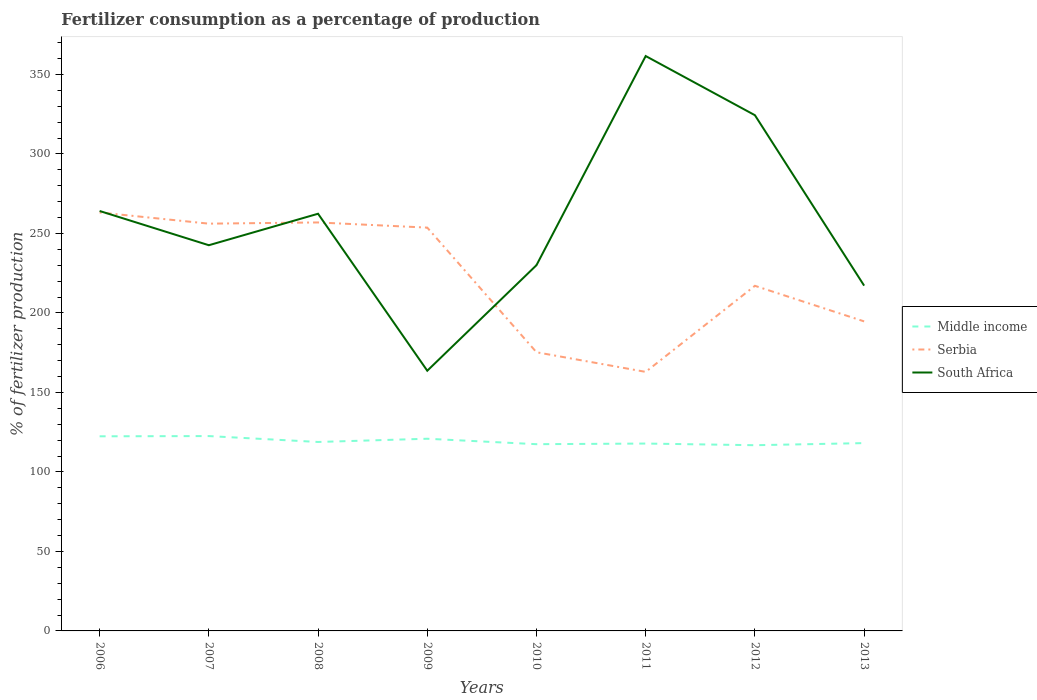How many different coloured lines are there?
Offer a terse response. 3. Across all years, what is the maximum percentage of fertilizers consumed in Serbia?
Provide a succinct answer. 162.92. What is the total percentage of fertilizers consumed in South Africa in the graph?
Make the answer very short. -118.98. What is the difference between the highest and the second highest percentage of fertilizers consumed in Middle income?
Your answer should be very brief. 5.74. How many lines are there?
Provide a short and direct response. 3. What is the difference between two consecutive major ticks on the Y-axis?
Offer a very short reply. 50. Where does the legend appear in the graph?
Keep it short and to the point. Center right. What is the title of the graph?
Offer a terse response. Fertilizer consumption as a percentage of production. Does "Italy" appear as one of the legend labels in the graph?
Keep it short and to the point. No. What is the label or title of the X-axis?
Offer a terse response. Years. What is the label or title of the Y-axis?
Keep it short and to the point. % of fertilizer production. What is the % of fertilizer production in Middle income in 2006?
Offer a very short reply. 122.4. What is the % of fertilizer production of Serbia in 2006?
Provide a short and direct response. 263.16. What is the % of fertilizer production of South Africa in 2006?
Offer a very short reply. 264.1. What is the % of fertilizer production of Middle income in 2007?
Offer a very short reply. 122.54. What is the % of fertilizer production in Serbia in 2007?
Your response must be concise. 256.14. What is the % of fertilizer production of South Africa in 2007?
Offer a very short reply. 242.57. What is the % of fertilizer production in Middle income in 2008?
Give a very brief answer. 118.83. What is the % of fertilizer production of Serbia in 2008?
Provide a succinct answer. 256.9. What is the % of fertilizer production of South Africa in 2008?
Give a very brief answer. 262.37. What is the % of fertilizer production in Middle income in 2009?
Your response must be concise. 120.87. What is the % of fertilizer production in Serbia in 2009?
Offer a very short reply. 253.64. What is the % of fertilizer production in South Africa in 2009?
Give a very brief answer. 163.64. What is the % of fertilizer production in Middle income in 2010?
Offer a very short reply. 117.44. What is the % of fertilizer production in Serbia in 2010?
Offer a terse response. 175.26. What is the % of fertilizer production of South Africa in 2010?
Your answer should be compact. 230.02. What is the % of fertilizer production in Middle income in 2011?
Provide a succinct answer. 117.84. What is the % of fertilizer production in Serbia in 2011?
Your answer should be compact. 162.92. What is the % of fertilizer production of South Africa in 2011?
Make the answer very short. 361.56. What is the % of fertilizer production of Middle income in 2012?
Keep it short and to the point. 116.8. What is the % of fertilizer production of Serbia in 2012?
Offer a terse response. 217.05. What is the % of fertilizer production of South Africa in 2012?
Your answer should be compact. 324.34. What is the % of fertilizer production of Middle income in 2013?
Provide a short and direct response. 118.12. What is the % of fertilizer production in Serbia in 2013?
Your answer should be very brief. 194.67. What is the % of fertilizer production of South Africa in 2013?
Offer a terse response. 217.16. Across all years, what is the maximum % of fertilizer production in Middle income?
Ensure brevity in your answer.  122.54. Across all years, what is the maximum % of fertilizer production in Serbia?
Your response must be concise. 263.16. Across all years, what is the maximum % of fertilizer production of South Africa?
Offer a terse response. 361.56. Across all years, what is the minimum % of fertilizer production in Middle income?
Give a very brief answer. 116.8. Across all years, what is the minimum % of fertilizer production of Serbia?
Provide a succinct answer. 162.92. Across all years, what is the minimum % of fertilizer production in South Africa?
Your answer should be compact. 163.64. What is the total % of fertilizer production of Middle income in the graph?
Keep it short and to the point. 954.83. What is the total % of fertilizer production of Serbia in the graph?
Your response must be concise. 1779.73. What is the total % of fertilizer production in South Africa in the graph?
Offer a terse response. 2065.76. What is the difference between the % of fertilizer production of Middle income in 2006 and that in 2007?
Make the answer very short. -0.14. What is the difference between the % of fertilizer production of Serbia in 2006 and that in 2007?
Your answer should be very brief. 7.03. What is the difference between the % of fertilizer production in South Africa in 2006 and that in 2007?
Give a very brief answer. 21.53. What is the difference between the % of fertilizer production in Middle income in 2006 and that in 2008?
Offer a very short reply. 3.57. What is the difference between the % of fertilizer production of Serbia in 2006 and that in 2008?
Ensure brevity in your answer.  6.27. What is the difference between the % of fertilizer production in South Africa in 2006 and that in 2008?
Keep it short and to the point. 1.73. What is the difference between the % of fertilizer production of Middle income in 2006 and that in 2009?
Your response must be concise. 1.53. What is the difference between the % of fertilizer production of Serbia in 2006 and that in 2009?
Your response must be concise. 9.52. What is the difference between the % of fertilizer production in South Africa in 2006 and that in 2009?
Ensure brevity in your answer.  100.47. What is the difference between the % of fertilizer production in Middle income in 2006 and that in 2010?
Your answer should be very brief. 4.96. What is the difference between the % of fertilizer production of Serbia in 2006 and that in 2010?
Make the answer very short. 87.91. What is the difference between the % of fertilizer production in South Africa in 2006 and that in 2010?
Your answer should be compact. 34.08. What is the difference between the % of fertilizer production of Middle income in 2006 and that in 2011?
Your answer should be very brief. 4.56. What is the difference between the % of fertilizer production in Serbia in 2006 and that in 2011?
Your answer should be very brief. 100.25. What is the difference between the % of fertilizer production of South Africa in 2006 and that in 2011?
Offer a very short reply. -97.45. What is the difference between the % of fertilizer production in Middle income in 2006 and that in 2012?
Offer a very short reply. 5.6. What is the difference between the % of fertilizer production in Serbia in 2006 and that in 2012?
Your answer should be very brief. 46.12. What is the difference between the % of fertilizer production of South Africa in 2006 and that in 2012?
Your answer should be compact. -60.24. What is the difference between the % of fertilizer production of Middle income in 2006 and that in 2013?
Offer a terse response. 4.28. What is the difference between the % of fertilizer production of Serbia in 2006 and that in 2013?
Make the answer very short. 68.49. What is the difference between the % of fertilizer production in South Africa in 2006 and that in 2013?
Ensure brevity in your answer.  46.95. What is the difference between the % of fertilizer production in Middle income in 2007 and that in 2008?
Your answer should be compact. 3.71. What is the difference between the % of fertilizer production of Serbia in 2007 and that in 2008?
Ensure brevity in your answer.  -0.76. What is the difference between the % of fertilizer production in South Africa in 2007 and that in 2008?
Offer a terse response. -19.8. What is the difference between the % of fertilizer production of Middle income in 2007 and that in 2009?
Provide a succinct answer. 1.68. What is the difference between the % of fertilizer production in Serbia in 2007 and that in 2009?
Ensure brevity in your answer.  2.49. What is the difference between the % of fertilizer production in South Africa in 2007 and that in 2009?
Provide a succinct answer. 78.93. What is the difference between the % of fertilizer production in Middle income in 2007 and that in 2010?
Your answer should be very brief. 5.1. What is the difference between the % of fertilizer production of Serbia in 2007 and that in 2010?
Provide a short and direct response. 80.88. What is the difference between the % of fertilizer production of South Africa in 2007 and that in 2010?
Make the answer very short. 12.55. What is the difference between the % of fertilizer production in Middle income in 2007 and that in 2011?
Your answer should be very brief. 4.71. What is the difference between the % of fertilizer production in Serbia in 2007 and that in 2011?
Your answer should be very brief. 93.22. What is the difference between the % of fertilizer production in South Africa in 2007 and that in 2011?
Keep it short and to the point. -118.98. What is the difference between the % of fertilizer production of Middle income in 2007 and that in 2012?
Your answer should be very brief. 5.74. What is the difference between the % of fertilizer production in Serbia in 2007 and that in 2012?
Your answer should be very brief. 39.09. What is the difference between the % of fertilizer production in South Africa in 2007 and that in 2012?
Provide a short and direct response. -81.77. What is the difference between the % of fertilizer production in Middle income in 2007 and that in 2013?
Provide a succinct answer. 4.42. What is the difference between the % of fertilizer production of Serbia in 2007 and that in 2013?
Keep it short and to the point. 61.47. What is the difference between the % of fertilizer production of South Africa in 2007 and that in 2013?
Provide a succinct answer. 25.41. What is the difference between the % of fertilizer production in Middle income in 2008 and that in 2009?
Your answer should be very brief. -2.03. What is the difference between the % of fertilizer production of Serbia in 2008 and that in 2009?
Make the answer very short. 3.25. What is the difference between the % of fertilizer production of South Africa in 2008 and that in 2009?
Keep it short and to the point. 98.73. What is the difference between the % of fertilizer production of Middle income in 2008 and that in 2010?
Your answer should be compact. 1.39. What is the difference between the % of fertilizer production in Serbia in 2008 and that in 2010?
Your answer should be compact. 81.64. What is the difference between the % of fertilizer production in South Africa in 2008 and that in 2010?
Offer a terse response. 32.34. What is the difference between the % of fertilizer production of Serbia in 2008 and that in 2011?
Offer a very short reply. 93.98. What is the difference between the % of fertilizer production of South Africa in 2008 and that in 2011?
Your answer should be compact. -99.19. What is the difference between the % of fertilizer production of Middle income in 2008 and that in 2012?
Your answer should be very brief. 2.03. What is the difference between the % of fertilizer production of Serbia in 2008 and that in 2012?
Your answer should be very brief. 39.85. What is the difference between the % of fertilizer production of South Africa in 2008 and that in 2012?
Offer a terse response. -61.97. What is the difference between the % of fertilizer production of Middle income in 2008 and that in 2013?
Give a very brief answer. 0.71. What is the difference between the % of fertilizer production in Serbia in 2008 and that in 2013?
Your response must be concise. 62.22. What is the difference between the % of fertilizer production of South Africa in 2008 and that in 2013?
Keep it short and to the point. 45.21. What is the difference between the % of fertilizer production in Middle income in 2009 and that in 2010?
Give a very brief answer. 3.43. What is the difference between the % of fertilizer production in Serbia in 2009 and that in 2010?
Your response must be concise. 78.39. What is the difference between the % of fertilizer production in South Africa in 2009 and that in 2010?
Make the answer very short. -66.39. What is the difference between the % of fertilizer production of Middle income in 2009 and that in 2011?
Offer a very short reply. 3.03. What is the difference between the % of fertilizer production in Serbia in 2009 and that in 2011?
Make the answer very short. 90.73. What is the difference between the % of fertilizer production in South Africa in 2009 and that in 2011?
Provide a short and direct response. -197.92. What is the difference between the % of fertilizer production in Middle income in 2009 and that in 2012?
Offer a very short reply. 4.07. What is the difference between the % of fertilizer production of Serbia in 2009 and that in 2012?
Keep it short and to the point. 36.6. What is the difference between the % of fertilizer production of South Africa in 2009 and that in 2012?
Offer a terse response. -160.71. What is the difference between the % of fertilizer production of Middle income in 2009 and that in 2013?
Make the answer very short. 2.75. What is the difference between the % of fertilizer production in Serbia in 2009 and that in 2013?
Offer a very short reply. 58.97. What is the difference between the % of fertilizer production of South Africa in 2009 and that in 2013?
Your answer should be very brief. -53.52. What is the difference between the % of fertilizer production in Middle income in 2010 and that in 2011?
Offer a terse response. -0.4. What is the difference between the % of fertilizer production in Serbia in 2010 and that in 2011?
Your answer should be compact. 12.34. What is the difference between the % of fertilizer production in South Africa in 2010 and that in 2011?
Provide a succinct answer. -131.53. What is the difference between the % of fertilizer production in Middle income in 2010 and that in 2012?
Provide a short and direct response. 0.64. What is the difference between the % of fertilizer production in Serbia in 2010 and that in 2012?
Keep it short and to the point. -41.79. What is the difference between the % of fertilizer production of South Africa in 2010 and that in 2012?
Your response must be concise. -94.32. What is the difference between the % of fertilizer production in Middle income in 2010 and that in 2013?
Give a very brief answer. -0.68. What is the difference between the % of fertilizer production in Serbia in 2010 and that in 2013?
Make the answer very short. -19.41. What is the difference between the % of fertilizer production of South Africa in 2010 and that in 2013?
Keep it short and to the point. 12.87. What is the difference between the % of fertilizer production of Middle income in 2011 and that in 2012?
Ensure brevity in your answer.  1.04. What is the difference between the % of fertilizer production of Serbia in 2011 and that in 2012?
Offer a terse response. -54.13. What is the difference between the % of fertilizer production in South Africa in 2011 and that in 2012?
Ensure brevity in your answer.  37.21. What is the difference between the % of fertilizer production in Middle income in 2011 and that in 2013?
Ensure brevity in your answer.  -0.28. What is the difference between the % of fertilizer production of Serbia in 2011 and that in 2013?
Provide a short and direct response. -31.76. What is the difference between the % of fertilizer production of South Africa in 2011 and that in 2013?
Make the answer very short. 144.4. What is the difference between the % of fertilizer production in Middle income in 2012 and that in 2013?
Provide a short and direct response. -1.32. What is the difference between the % of fertilizer production in Serbia in 2012 and that in 2013?
Offer a terse response. 22.37. What is the difference between the % of fertilizer production of South Africa in 2012 and that in 2013?
Provide a short and direct response. 107.19. What is the difference between the % of fertilizer production in Middle income in 2006 and the % of fertilizer production in Serbia in 2007?
Offer a terse response. -133.74. What is the difference between the % of fertilizer production of Middle income in 2006 and the % of fertilizer production of South Africa in 2007?
Keep it short and to the point. -120.17. What is the difference between the % of fertilizer production in Serbia in 2006 and the % of fertilizer production in South Africa in 2007?
Keep it short and to the point. 20.59. What is the difference between the % of fertilizer production of Middle income in 2006 and the % of fertilizer production of Serbia in 2008?
Your answer should be very brief. -134.5. What is the difference between the % of fertilizer production in Middle income in 2006 and the % of fertilizer production in South Africa in 2008?
Offer a terse response. -139.97. What is the difference between the % of fertilizer production of Serbia in 2006 and the % of fertilizer production of South Africa in 2008?
Your response must be concise. 0.8. What is the difference between the % of fertilizer production of Middle income in 2006 and the % of fertilizer production of Serbia in 2009?
Your response must be concise. -131.25. What is the difference between the % of fertilizer production in Middle income in 2006 and the % of fertilizer production in South Africa in 2009?
Provide a succinct answer. -41.24. What is the difference between the % of fertilizer production in Serbia in 2006 and the % of fertilizer production in South Africa in 2009?
Provide a short and direct response. 99.53. What is the difference between the % of fertilizer production in Middle income in 2006 and the % of fertilizer production in Serbia in 2010?
Give a very brief answer. -52.86. What is the difference between the % of fertilizer production in Middle income in 2006 and the % of fertilizer production in South Africa in 2010?
Give a very brief answer. -107.63. What is the difference between the % of fertilizer production of Serbia in 2006 and the % of fertilizer production of South Africa in 2010?
Your answer should be very brief. 33.14. What is the difference between the % of fertilizer production in Middle income in 2006 and the % of fertilizer production in Serbia in 2011?
Ensure brevity in your answer.  -40.52. What is the difference between the % of fertilizer production in Middle income in 2006 and the % of fertilizer production in South Africa in 2011?
Offer a very short reply. -239.16. What is the difference between the % of fertilizer production of Serbia in 2006 and the % of fertilizer production of South Africa in 2011?
Offer a terse response. -98.39. What is the difference between the % of fertilizer production of Middle income in 2006 and the % of fertilizer production of Serbia in 2012?
Provide a succinct answer. -94.65. What is the difference between the % of fertilizer production of Middle income in 2006 and the % of fertilizer production of South Africa in 2012?
Give a very brief answer. -201.94. What is the difference between the % of fertilizer production of Serbia in 2006 and the % of fertilizer production of South Africa in 2012?
Your answer should be very brief. -61.18. What is the difference between the % of fertilizer production of Middle income in 2006 and the % of fertilizer production of Serbia in 2013?
Keep it short and to the point. -72.27. What is the difference between the % of fertilizer production of Middle income in 2006 and the % of fertilizer production of South Africa in 2013?
Your response must be concise. -94.76. What is the difference between the % of fertilizer production of Serbia in 2006 and the % of fertilizer production of South Africa in 2013?
Make the answer very short. 46.01. What is the difference between the % of fertilizer production of Middle income in 2007 and the % of fertilizer production of Serbia in 2008?
Offer a terse response. -134.35. What is the difference between the % of fertilizer production of Middle income in 2007 and the % of fertilizer production of South Africa in 2008?
Keep it short and to the point. -139.83. What is the difference between the % of fertilizer production of Serbia in 2007 and the % of fertilizer production of South Africa in 2008?
Your answer should be very brief. -6.23. What is the difference between the % of fertilizer production of Middle income in 2007 and the % of fertilizer production of Serbia in 2009?
Make the answer very short. -131.1. What is the difference between the % of fertilizer production of Middle income in 2007 and the % of fertilizer production of South Africa in 2009?
Your answer should be compact. -41.09. What is the difference between the % of fertilizer production in Serbia in 2007 and the % of fertilizer production in South Africa in 2009?
Your answer should be compact. 92.5. What is the difference between the % of fertilizer production of Middle income in 2007 and the % of fertilizer production of Serbia in 2010?
Your answer should be compact. -52.71. What is the difference between the % of fertilizer production of Middle income in 2007 and the % of fertilizer production of South Africa in 2010?
Ensure brevity in your answer.  -107.48. What is the difference between the % of fertilizer production in Serbia in 2007 and the % of fertilizer production in South Africa in 2010?
Make the answer very short. 26.11. What is the difference between the % of fertilizer production of Middle income in 2007 and the % of fertilizer production of Serbia in 2011?
Your response must be concise. -40.37. What is the difference between the % of fertilizer production in Middle income in 2007 and the % of fertilizer production in South Africa in 2011?
Your answer should be very brief. -239.01. What is the difference between the % of fertilizer production of Serbia in 2007 and the % of fertilizer production of South Africa in 2011?
Ensure brevity in your answer.  -105.42. What is the difference between the % of fertilizer production of Middle income in 2007 and the % of fertilizer production of Serbia in 2012?
Make the answer very short. -94.5. What is the difference between the % of fertilizer production in Middle income in 2007 and the % of fertilizer production in South Africa in 2012?
Offer a terse response. -201.8. What is the difference between the % of fertilizer production in Serbia in 2007 and the % of fertilizer production in South Africa in 2012?
Ensure brevity in your answer.  -68.2. What is the difference between the % of fertilizer production of Middle income in 2007 and the % of fertilizer production of Serbia in 2013?
Keep it short and to the point. -72.13. What is the difference between the % of fertilizer production of Middle income in 2007 and the % of fertilizer production of South Africa in 2013?
Offer a very short reply. -94.61. What is the difference between the % of fertilizer production in Serbia in 2007 and the % of fertilizer production in South Africa in 2013?
Your response must be concise. 38.98. What is the difference between the % of fertilizer production in Middle income in 2008 and the % of fertilizer production in Serbia in 2009?
Your answer should be very brief. -134.81. What is the difference between the % of fertilizer production of Middle income in 2008 and the % of fertilizer production of South Africa in 2009?
Make the answer very short. -44.8. What is the difference between the % of fertilizer production in Serbia in 2008 and the % of fertilizer production in South Africa in 2009?
Give a very brief answer. 93.26. What is the difference between the % of fertilizer production of Middle income in 2008 and the % of fertilizer production of Serbia in 2010?
Make the answer very short. -56.42. What is the difference between the % of fertilizer production in Middle income in 2008 and the % of fertilizer production in South Africa in 2010?
Your answer should be very brief. -111.19. What is the difference between the % of fertilizer production of Serbia in 2008 and the % of fertilizer production of South Africa in 2010?
Offer a very short reply. 26.87. What is the difference between the % of fertilizer production of Middle income in 2008 and the % of fertilizer production of Serbia in 2011?
Offer a terse response. -44.08. What is the difference between the % of fertilizer production of Middle income in 2008 and the % of fertilizer production of South Africa in 2011?
Give a very brief answer. -242.72. What is the difference between the % of fertilizer production of Serbia in 2008 and the % of fertilizer production of South Africa in 2011?
Provide a short and direct response. -104.66. What is the difference between the % of fertilizer production in Middle income in 2008 and the % of fertilizer production in Serbia in 2012?
Your answer should be very brief. -98.21. What is the difference between the % of fertilizer production of Middle income in 2008 and the % of fertilizer production of South Africa in 2012?
Your answer should be compact. -205.51. What is the difference between the % of fertilizer production of Serbia in 2008 and the % of fertilizer production of South Africa in 2012?
Make the answer very short. -67.45. What is the difference between the % of fertilizer production of Middle income in 2008 and the % of fertilizer production of Serbia in 2013?
Provide a short and direct response. -75.84. What is the difference between the % of fertilizer production of Middle income in 2008 and the % of fertilizer production of South Africa in 2013?
Your answer should be very brief. -98.32. What is the difference between the % of fertilizer production in Serbia in 2008 and the % of fertilizer production in South Africa in 2013?
Provide a short and direct response. 39.74. What is the difference between the % of fertilizer production in Middle income in 2009 and the % of fertilizer production in Serbia in 2010?
Provide a short and direct response. -54.39. What is the difference between the % of fertilizer production of Middle income in 2009 and the % of fertilizer production of South Africa in 2010?
Provide a short and direct response. -109.16. What is the difference between the % of fertilizer production of Serbia in 2009 and the % of fertilizer production of South Africa in 2010?
Offer a terse response. 23.62. What is the difference between the % of fertilizer production in Middle income in 2009 and the % of fertilizer production in Serbia in 2011?
Your answer should be very brief. -42.05. What is the difference between the % of fertilizer production in Middle income in 2009 and the % of fertilizer production in South Africa in 2011?
Provide a succinct answer. -240.69. What is the difference between the % of fertilizer production of Serbia in 2009 and the % of fertilizer production of South Africa in 2011?
Offer a terse response. -107.91. What is the difference between the % of fertilizer production of Middle income in 2009 and the % of fertilizer production of Serbia in 2012?
Give a very brief answer. -96.18. What is the difference between the % of fertilizer production in Middle income in 2009 and the % of fertilizer production in South Africa in 2012?
Offer a terse response. -203.48. What is the difference between the % of fertilizer production in Serbia in 2009 and the % of fertilizer production in South Africa in 2012?
Keep it short and to the point. -70.7. What is the difference between the % of fertilizer production of Middle income in 2009 and the % of fertilizer production of Serbia in 2013?
Provide a short and direct response. -73.81. What is the difference between the % of fertilizer production in Middle income in 2009 and the % of fertilizer production in South Africa in 2013?
Give a very brief answer. -96.29. What is the difference between the % of fertilizer production in Serbia in 2009 and the % of fertilizer production in South Africa in 2013?
Your answer should be compact. 36.49. What is the difference between the % of fertilizer production of Middle income in 2010 and the % of fertilizer production of Serbia in 2011?
Your answer should be compact. -45.48. What is the difference between the % of fertilizer production of Middle income in 2010 and the % of fertilizer production of South Africa in 2011?
Ensure brevity in your answer.  -244.12. What is the difference between the % of fertilizer production in Serbia in 2010 and the % of fertilizer production in South Africa in 2011?
Ensure brevity in your answer.  -186.3. What is the difference between the % of fertilizer production in Middle income in 2010 and the % of fertilizer production in Serbia in 2012?
Provide a succinct answer. -99.61. What is the difference between the % of fertilizer production of Middle income in 2010 and the % of fertilizer production of South Africa in 2012?
Your answer should be compact. -206.9. What is the difference between the % of fertilizer production in Serbia in 2010 and the % of fertilizer production in South Africa in 2012?
Offer a very short reply. -149.09. What is the difference between the % of fertilizer production in Middle income in 2010 and the % of fertilizer production in Serbia in 2013?
Your answer should be compact. -77.23. What is the difference between the % of fertilizer production in Middle income in 2010 and the % of fertilizer production in South Africa in 2013?
Your answer should be compact. -99.72. What is the difference between the % of fertilizer production in Serbia in 2010 and the % of fertilizer production in South Africa in 2013?
Your answer should be very brief. -41.9. What is the difference between the % of fertilizer production of Middle income in 2011 and the % of fertilizer production of Serbia in 2012?
Your answer should be very brief. -99.21. What is the difference between the % of fertilizer production of Middle income in 2011 and the % of fertilizer production of South Africa in 2012?
Give a very brief answer. -206.51. What is the difference between the % of fertilizer production of Serbia in 2011 and the % of fertilizer production of South Africa in 2012?
Provide a succinct answer. -161.43. What is the difference between the % of fertilizer production of Middle income in 2011 and the % of fertilizer production of Serbia in 2013?
Provide a succinct answer. -76.83. What is the difference between the % of fertilizer production in Middle income in 2011 and the % of fertilizer production in South Africa in 2013?
Give a very brief answer. -99.32. What is the difference between the % of fertilizer production of Serbia in 2011 and the % of fertilizer production of South Africa in 2013?
Ensure brevity in your answer.  -54.24. What is the difference between the % of fertilizer production in Middle income in 2012 and the % of fertilizer production in Serbia in 2013?
Offer a very short reply. -77.87. What is the difference between the % of fertilizer production in Middle income in 2012 and the % of fertilizer production in South Africa in 2013?
Give a very brief answer. -100.36. What is the difference between the % of fertilizer production in Serbia in 2012 and the % of fertilizer production in South Africa in 2013?
Keep it short and to the point. -0.11. What is the average % of fertilizer production in Middle income per year?
Your response must be concise. 119.35. What is the average % of fertilizer production in Serbia per year?
Your response must be concise. 222.47. What is the average % of fertilizer production in South Africa per year?
Offer a very short reply. 258.22. In the year 2006, what is the difference between the % of fertilizer production in Middle income and % of fertilizer production in Serbia?
Provide a short and direct response. -140.77. In the year 2006, what is the difference between the % of fertilizer production in Middle income and % of fertilizer production in South Africa?
Make the answer very short. -141.7. In the year 2006, what is the difference between the % of fertilizer production of Serbia and % of fertilizer production of South Africa?
Provide a succinct answer. -0.94. In the year 2007, what is the difference between the % of fertilizer production of Middle income and % of fertilizer production of Serbia?
Provide a short and direct response. -133.6. In the year 2007, what is the difference between the % of fertilizer production in Middle income and % of fertilizer production in South Africa?
Keep it short and to the point. -120.03. In the year 2007, what is the difference between the % of fertilizer production of Serbia and % of fertilizer production of South Africa?
Offer a terse response. 13.57. In the year 2008, what is the difference between the % of fertilizer production of Middle income and % of fertilizer production of Serbia?
Offer a terse response. -138.06. In the year 2008, what is the difference between the % of fertilizer production of Middle income and % of fertilizer production of South Africa?
Offer a very short reply. -143.54. In the year 2008, what is the difference between the % of fertilizer production of Serbia and % of fertilizer production of South Africa?
Keep it short and to the point. -5.47. In the year 2009, what is the difference between the % of fertilizer production of Middle income and % of fertilizer production of Serbia?
Your answer should be compact. -132.78. In the year 2009, what is the difference between the % of fertilizer production of Middle income and % of fertilizer production of South Africa?
Offer a very short reply. -42.77. In the year 2009, what is the difference between the % of fertilizer production in Serbia and % of fertilizer production in South Africa?
Offer a very short reply. 90.01. In the year 2010, what is the difference between the % of fertilizer production of Middle income and % of fertilizer production of Serbia?
Your answer should be very brief. -57.82. In the year 2010, what is the difference between the % of fertilizer production in Middle income and % of fertilizer production in South Africa?
Offer a very short reply. -112.59. In the year 2010, what is the difference between the % of fertilizer production of Serbia and % of fertilizer production of South Africa?
Your answer should be very brief. -54.77. In the year 2011, what is the difference between the % of fertilizer production of Middle income and % of fertilizer production of Serbia?
Ensure brevity in your answer.  -45.08. In the year 2011, what is the difference between the % of fertilizer production of Middle income and % of fertilizer production of South Africa?
Offer a terse response. -243.72. In the year 2011, what is the difference between the % of fertilizer production of Serbia and % of fertilizer production of South Africa?
Keep it short and to the point. -198.64. In the year 2012, what is the difference between the % of fertilizer production in Middle income and % of fertilizer production in Serbia?
Ensure brevity in your answer.  -100.25. In the year 2012, what is the difference between the % of fertilizer production in Middle income and % of fertilizer production in South Africa?
Keep it short and to the point. -207.54. In the year 2012, what is the difference between the % of fertilizer production in Serbia and % of fertilizer production in South Africa?
Provide a succinct answer. -107.3. In the year 2013, what is the difference between the % of fertilizer production in Middle income and % of fertilizer production in Serbia?
Keep it short and to the point. -76.55. In the year 2013, what is the difference between the % of fertilizer production in Middle income and % of fertilizer production in South Africa?
Give a very brief answer. -99.04. In the year 2013, what is the difference between the % of fertilizer production in Serbia and % of fertilizer production in South Africa?
Provide a succinct answer. -22.48. What is the ratio of the % of fertilizer production of Serbia in 2006 to that in 2007?
Provide a short and direct response. 1.03. What is the ratio of the % of fertilizer production in South Africa in 2006 to that in 2007?
Your answer should be compact. 1.09. What is the ratio of the % of fertilizer production of Serbia in 2006 to that in 2008?
Provide a short and direct response. 1.02. What is the ratio of the % of fertilizer production of South Africa in 2006 to that in 2008?
Keep it short and to the point. 1.01. What is the ratio of the % of fertilizer production in Middle income in 2006 to that in 2009?
Offer a very short reply. 1.01. What is the ratio of the % of fertilizer production of Serbia in 2006 to that in 2009?
Ensure brevity in your answer.  1.04. What is the ratio of the % of fertilizer production of South Africa in 2006 to that in 2009?
Your answer should be very brief. 1.61. What is the ratio of the % of fertilizer production of Middle income in 2006 to that in 2010?
Provide a succinct answer. 1.04. What is the ratio of the % of fertilizer production of Serbia in 2006 to that in 2010?
Give a very brief answer. 1.5. What is the ratio of the % of fertilizer production in South Africa in 2006 to that in 2010?
Provide a succinct answer. 1.15. What is the ratio of the % of fertilizer production of Middle income in 2006 to that in 2011?
Keep it short and to the point. 1.04. What is the ratio of the % of fertilizer production in Serbia in 2006 to that in 2011?
Provide a short and direct response. 1.62. What is the ratio of the % of fertilizer production of South Africa in 2006 to that in 2011?
Your answer should be compact. 0.73. What is the ratio of the % of fertilizer production of Middle income in 2006 to that in 2012?
Give a very brief answer. 1.05. What is the ratio of the % of fertilizer production of Serbia in 2006 to that in 2012?
Offer a very short reply. 1.21. What is the ratio of the % of fertilizer production in South Africa in 2006 to that in 2012?
Keep it short and to the point. 0.81. What is the ratio of the % of fertilizer production of Middle income in 2006 to that in 2013?
Provide a short and direct response. 1.04. What is the ratio of the % of fertilizer production of Serbia in 2006 to that in 2013?
Offer a very short reply. 1.35. What is the ratio of the % of fertilizer production of South Africa in 2006 to that in 2013?
Make the answer very short. 1.22. What is the ratio of the % of fertilizer production of Middle income in 2007 to that in 2008?
Give a very brief answer. 1.03. What is the ratio of the % of fertilizer production in South Africa in 2007 to that in 2008?
Provide a succinct answer. 0.92. What is the ratio of the % of fertilizer production in Middle income in 2007 to that in 2009?
Ensure brevity in your answer.  1.01. What is the ratio of the % of fertilizer production of Serbia in 2007 to that in 2009?
Ensure brevity in your answer.  1.01. What is the ratio of the % of fertilizer production of South Africa in 2007 to that in 2009?
Offer a very short reply. 1.48. What is the ratio of the % of fertilizer production of Middle income in 2007 to that in 2010?
Keep it short and to the point. 1.04. What is the ratio of the % of fertilizer production of Serbia in 2007 to that in 2010?
Provide a short and direct response. 1.46. What is the ratio of the % of fertilizer production of South Africa in 2007 to that in 2010?
Offer a very short reply. 1.05. What is the ratio of the % of fertilizer production in Middle income in 2007 to that in 2011?
Keep it short and to the point. 1.04. What is the ratio of the % of fertilizer production in Serbia in 2007 to that in 2011?
Make the answer very short. 1.57. What is the ratio of the % of fertilizer production in South Africa in 2007 to that in 2011?
Give a very brief answer. 0.67. What is the ratio of the % of fertilizer production of Middle income in 2007 to that in 2012?
Ensure brevity in your answer.  1.05. What is the ratio of the % of fertilizer production of Serbia in 2007 to that in 2012?
Give a very brief answer. 1.18. What is the ratio of the % of fertilizer production of South Africa in 2007 to that in 2012?
Keep it short and to the point. 0.75. What is the ratio of the % of fertilizer production of Middle income in 2007 to that in 2013?
Offer a very short reply. 1.04. What is the ratio of the % of fertilizer production in Serbia in 2007 to that in 2013?
Provide a short and direct response. 1.32. What is the ratio of the % of fertilizer production in South Africa in 2007 to that in 2013?
Your answer should be very brief. 1.12. What is the ratio of the % of fertilizer production in Middle income in 2008 to that in 2009?
Provide a short and direct response. 0.98. What is the ratio of the % of fertilizer production in Serbia in 2008 to that in 2009?
Keep it short and to the point. 1.01. What is the ratio of the % of fertilizer production of South Africa in 2008 to that in 2009?
Offer a very short reply. 1.6. What is the ratio of the % of fertilizer production of Middle income in 2008 to that in 2010?
Offer a terse response. 1.01. What is the ratio of the % of fertilizer production of Serbia in 2008 to that in 2010?
Provide a succinct answer. 1.47. What is the ratio of the % of fertilizer production of South Africa in 2008 to that in 2010?
Offer a terse response. 1.14. What is the ratio of the % of fertilizer production of Middle income in 2008 to that in 2011?
Your answer should be compact. 1.01. What is the ratio of the % of fertilizer production of Serbia in 2008 to that in 2011?
Give a very brief answer. 1.58. What is the ratio of the % of fertilizer production in South Africa in 2008 to that in 2011?
Provide a short and direct response. 0.73. What is the ratio of the % of fertilizer production of Middle income in 2008 to that in 2012?
Give a very brief answer. 1.02. What is the ratio of the % of fertilizer production of Serbia in 2008 to that in 2012?
Make the answer very short. 1.18. What is the ratio of the % of fertilizer production of South Africa in 2008 to that in 2012?
Provide a succinct answer. 0.81. What is the ratio of the % of fertilizer production in Middle income in 2008 to that in 2013?
Your answer should be very brief. 1.01. What is the ratio of the % of fertilizer production in Serbia in 2008 to that in 2013?
Ensure brevity in your answer.  1.32. What is the ratio of the % of fertilizer production of South Africa in 2008 to that in 2013?
Give a very brief answer. 1.21. What is the ratio of the % of fertilizer production in Middle income in 2009 to that in 2010?
Offer a very short reply. 1.03. What is the ratio of the % of fertilizer production of Serbia in 2009 to that in 2010?
Your response must be concise. 1.45. What is the ratio of the % of fertilizer production in South Africa in 2009 to that in 2010?
Offer a terse response. 0.71. What is the ratio of the % of fertilizer production in Middle income in 2009 to that in 2011?
Your answer should be compact. 1.03. What is the ratio of the % of fertilizer production in Serbia in 2009 to that in 2011?
Keep it short and to the point. 1.56. What is the ratio of the % of fertilizer production of South Africa in 2009 to that in 2011?
Make the answer very short. 0.45. What is the ratio of the % of fertilizer production of Middle income in 2009 to that in 2012?
Keep it short and to the point. 1.03. What is the ratio of the % of fertilizer production in Serbia in 2009 to that in 2012?
Keep it short and to the point. 1.17. What is the ratio of the % of fertilizer production of South Africa in 2009 to that in 2012?
Offer a terse response. 0.5. What is the ratio of the % of fertilizer production in Middle income in 2009 to that in 2013?
Keep it short and to the point. 1.02. What is the ratio of the % of fertilizer production in Serbia in 2009 to that in 2013?
Provide a succinct answer. 1.3. What is the ratio of the % of fertilizer production of South Africa in 2009 to that in 2013?
Make the answer very short. 0.75. What is the ratio of the % of fertilizer production of Serbia in 2010 to that in 2011?
Ensure brevity in your answer.  1.08. What is the ratio of the % of fertilizer production in South Africa in 2010 to that in 2011?
Make the answer very short. 0.64. What is the ratio of the % of fertilizer production in Middle income in 2010 to that in 2012?
Ensure brevity in your answer.  1.01. What is the ratio of the % of fertilizer production of Serbia in 2010 to that in 2012?
Offer a very short reply. 0.81. What is the ratio of the % of fertilizer production of South Africa in 2010 to that in 2012?
Your answer should be very brief. 0.71. What is the ratio of the % of fertilizer production of Middle income in 2010 to that in 2013?
Your response must be concise. 0.99. What is the ratio of the % of fertilizer production in Serbia in 2010 to that in 2013?
Offer a terse response. 0.9. What is the ratio of the % of fertilizer production in South Africa in 2010 to that in 2013?
Make the answer very short. 1.06. What is the ratio of the % of fertilizer production in Middle income in 2011 to that in 2012?
Keep it short and to the point. 1.01. What is the ratio of the % of fertilizer production in Serbia in 2011 to that in 2012?
Provide a short and direct response. 0.75. What is the ratio of the % of fertilizer production of South Africa in 2011 to that in 2012?
Make the answer very short. 1.11. What is the ratio of the % of fertilizer production of Middle income in 2011 to that in 2013?
Your response must be concise. 1. What is the ratio of the % of fertilizer production of Serbia in 2011 to that in 2013?
Give a very brief answer. 0.84. What is the ratio of the % of fertilizer production of South Africa in 2011 to that in 2013?
Provide a short and direct response. 1.67. What is the ratio of the % of fertilizer production in Middle income in 2012 to that in 2013?
Provide a short and direct response. 0.99. What is the ratio of the % of fertilizer production in Serbia in 2012 to that in 2013?
Your answer should be very brief. 1.11. What is the ratio of the % of fertilizer production of South Africa in 2012 to that in 2013?
Keep it short and to the point. 1.49. What is the difference between the highest and the second highest % of fertilizer production in Middle income?
Ensure brevity in your answer.  0.14. What is the difference between the highest and the second highest % of fertilizer production in Serbia?
Keep it short and to the point. 6.27. What is the difference between the highest and the second highest % of fertilizer production of South Africa?
Offer a very short reply. 37.21. What is the difference between the highest and the lowest % of fertilizer production of Middle income?
Give a very brief answer. 5.74. What is the difference between the highest and the lowest % of fertilizer production in Serbia?
Your response must be concise. 100.25. What is the difference between the highest and the lowest % of fertilizer production in South Africa?
Provide a succinct answer. 197.92. 